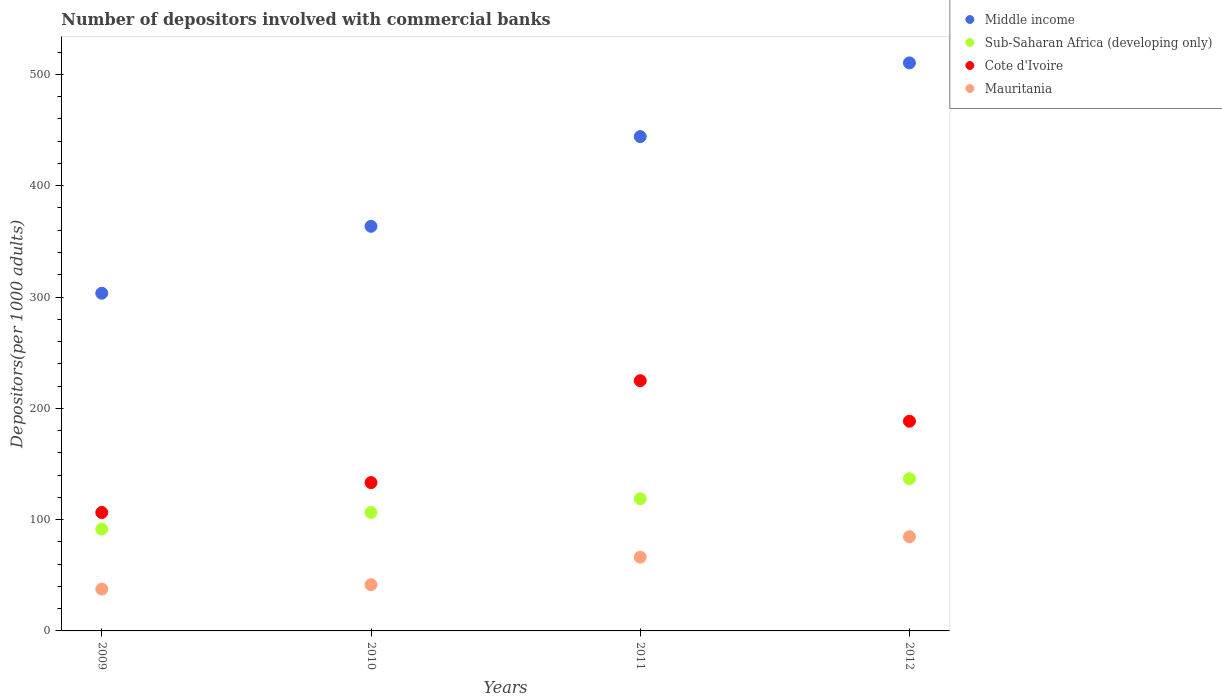What is the number of depositors involved with commercial banks in Middle income in 2012?
Offer a very short reply. 510.34. Across all years, what is the maximum number of depositors involved with commercial banks in Cote d'Ivoire?
Your answer should be compact. 224.81. Across all years, what is the minimum number of depositors involved with commercial banks in Cote d'Ivoire?
Your answer should be very brief. 106.41. What is the total number of depositors involved with commercial banks in Mauritania in the graph?
Your answer should be compact. 229.98. What is the difference between the number of depositors involved with commercial banks in Middle income in 2009 and that in 2011?
Provide a succinct answer. -140.73. What is the difference between the number of depositors involved with commercial banks in Mauritania in 2011 and the number of depositors involved with commercial banks in Middle income in 2012?
Your answer should be very brief. -444.11. What is the average number of depositors involved with commercial banks in Mauritania per year?
Offer a very short reply. 57.5. In the year 2012, what is the difference between the number of depositors involved with commercial banks in Middle income and number of depositors involved with commercial banks in Cote d'Ivoire?
Keep it short and to the point. 321.94. What is the ratio of the number of depositors involved with commercial banks in Sub-Saharan Africa (developing only) in 2009 to that in 2011?
Your answer should be very brief. 0.77. Is the number of depositors involved with commercial banks in Cote d'Ivoire in 2010 less than that in 2011?
Ensure brevity in your answer.  Yes. What is the difference between the highest and the second highest number of depositors involved with commercial banks in Cote d'Ivoire?
Your answer should be very brief. 36.42. What is the difference between the highest and the lowest number of depositors involved with commercial banks in Cote d'Ivoire?
Offer a terse response. 118.41. In how many years, is the number of depositors involved with commercial banks in Sub-Saharan Africa (developing only) greater than the average number of depositors involved with commercial banks in Sub-Saharan Africa (developing only) taken over all years?
Your response must be concise. 2. Is it the case that in every year, the sum of the number of depositors involved with commercial banks in Mauritania and number of depositors involved with commercial banks in Sub-Saharan Africa (developing only)  is greater than the sum of number of depositors involved with commercial banks in Cote d'Ivoire and number of depositors involved with commercial banks in Middle income?
Keep it short and to the point. No. Is it the case that in every year, the sum of the number of depositors involved with commercial banks in Sub-Saharan Africa (developing only) and number of depositors involved with commercial banks in Cote d'Ivoire  is greater than the number of depositors involved with commercial banks in Mauritania?
Give a very brief answer. Yes. Does the number of depositors involved with commercial banks in Sub-Saharan Africa (developing only) monotonically increase over the years?
Your answer should be very brief. Yes. How many dotlines are there?
Give a very brief answer. 4. What is the difference between two consecutive major ticks on the Y-axis?
Provide a succinct answer. 100. Are the values on the major ticks of Y-axis written in scientific E-notation?
Your answer should be compact. No. How are the legend labels stacked?
Provide a short and direct response. Vertical. What is the title of the graph?
Keep it short and to the point. Number of depositors involved with commercial banks. What is the label or title of the X-axis?
Offer a very short reply. Years. What is the label or title of the Y-axis?
Ensure brevity in your answer.  Depositors(per 1000 adults). What is the Depositors(per 1000 adults) in Middle income in 2009?
Give a very brief answer. 303.38. What is the Depositors(per 1000 adults) of Sub-Saharan Africa (developing only) in 2009?
Keep it short and to the point. 91.54. What is the Depositors(per 1000 adults) in Cote d'Ivoire in 2009?
Your answer should be compact. 106.41. What is the Depositors(per 1000 adults) of Mauritania in 2009?
Provide a short and direct response. 37.6. What is the Depositors(per 1000 adults) in Middle income in 2010?
Keep it short and to the point. 363.5. What is the Depositors(per 1000 adults) in Sub-Saharan Africa (developing only) in 2010?
Your response must be concise. 106.49. What is the Depositors(per 1000 adults) in Cote d'Ivoire in 2010?
Offer a very short reply. 133.26. What is the Depositors(per 1000 adults) in Mauritania in 2010?
Offer a very short reply. 41.54. What is the Depositors(per 1000 adults) in Middle income in 2011?
Keep it short and to the point. 444.11. What is the Depositors(per 1000 adults) in Sub-Saharan Africa (developing only) in 2011?
Offer a terse response. 118.8. What is the Depositors(per 1000 adults) of Cote d'Ivoire in 2011?
Give a very brief answer. 224.81. What is the Depositors(per 1000 adults) of Mauritania in 2011?
Provide a succinct answer. 66.23. What is the Depositors(per 1000 adults) of Middle income in 2012?
Provide a succinct answer. 510.34. What is the Depositors(per 1000 adults) in Sub-Saharan Africa (developing only) in 2012?
Ensure brevity in your answer.  136.78. What is the Depositors(per 1000 adults) of Cote d'Ivoire in 2012?
Offer a terse response. 188.4. What is the Depositors(per 1000 adults) of Mauritania in 2012?
Your response must be concise. 84.61. Across all years, what is the maximum Depositors(per 1000 adults) in Middle income?
Your response must be concise. 510.34. Across all years, what is the maximum Depositors(per 1000 adults) of Sub-Saharan Africa (developing only)?
Provide a short and direct response. 136.78. Across all years, what is the maximum Depositors(per 1000 adults) of Cote d'Ivoire?
Keep it short and to the point. 224.81. Across all years, what is the maximum Depositors(per 1000 adults) in Mauritania?
Your answer should be very brief. 84.61. Across all years, what is the minimum Depositors(per 1000 adults) of Middle income?
Offer a terse response. 303.38. Across all years, what is the minimum Depositors(per 1000 adults) of Sub-Saharan Africa (developing only)?
Your answer should be very brief. 91.54. Across all years, what is the minimum Depositors(per 1000 adults) of Cote d'Ivoire?
Keep it short and to the point. 106.41. Across all years, what is the minimum Depositors(per 1000 adults) of Mauritania?
Your answer should be very brief. 37.6. What is the total Depositors(per 1000 adults) of Middle income in the graph?
Your response must be concise. 1621.33. What is the total Depositors(per 1000 adults) of Sub-Saharan Africa (developing only) in the graph?
Offer a terse response. 453.62. What is the total Depositors(per 1000 adults) of Cote d'Ivoire in the graph?
Give a very brief answer. 652.87. What is the total Depositors(per 1000 adults) in Mauritania in the graph?
Your response must be concise. 229.98. What is the difference between the Depositors(per 1000 adults) of Middle income in 2009 and that in 2010?
Your answer should be very brief. -60.11. What is the difference between the Depositors(per 1000 adults) of Sub-Saharan Africa (developing only) in 2009 and that in 2010?
Provide a short and direct response. -14.95. What is the difference between the Depositors(per 1000 adults) of Cote d'Ivoire in 2009 and that in 2010?
Ensure brevity in your answer.  -26.85. What is the difference between the Depositors(per 1000 adults) in Mauritania in 2009 and that in 2010?
Offer a terse response. -3.93. What is the difference between the Depositors(per 1000 adults) of Middle income in 2009 and that in 2011?
Your response must be concise. -140.73. What is the difference between the Depositors(per 1000 adults) of Sub-Saharan Africa (developing only) in 2009 and that in 2011?
Make the answer very short. -27.26. What is the difference between the Depositors(per 1000 adults) in Cote d'Ivoire in 2009 and that in 2011?
Provide a succinct answer. -118.41. What is the difference between the Depositors(per 1000 adults) of Mauritania in 2009 and that in 2011?
Provide a succinct answer. -28.63. What is the difference between the Depositors(per 1000 adults) of Middle income in 2009 and that in 2012?
Keep it short and to the point. -206.95. What is the difference between the Depositors(per 1000 adults) in Sub-Saharan Africa (developing only) in 2009 and that in 2012?
Give a very brief answer. -45.24. What is the difference between the Depositors(per 1000 adults) of Cote d'Ivoire in 2009 and that in 2012?
Ensure brevity in your answer.  -81.99. What is the difference between the Depositors(per 1000 adults) of Mauritania in 2009 and that in 2012?
Keep it short and to the point. -47.01. What is the difference between the Depositors(per 1000 adults) of Middle income in 2010 and that in 2011?
Keep it short and to the point. -80.61. What is the difference between the Depositors(per 1000 adults) of Sub-Saharan Africa (developing only) in 2010 and that in 2011?
Ensure brevity in your answer.  -12.31. What is the difference between the Depositors(per 1000 adults) in Cote d'Ivoire in 2010 and that in 2011?
Keep it short and to the point. -91.56. What is the difference between the Depositors(per 1000 adults) of Mauritania in 2010 and that in 2011?
Ensure brevity in your answer.  -24.69. What is the difference between the Depositors(per 1000 adults) in Middle income in 2010 and that in 2012?
Ensure brevity in your answer.  -146.84. What is the difference between the Depositors(per 1000 adults) in Sub-Saharan Africa (developing only) in 2010 and that in 2012?
Ensure brevity in your answer.  -30.29. What is the difference between the Depositors(per 1000 adults) of Cote d'Ivoire in 2010 and that in 2012?
Provide a succinct answer. -55.14. What is the difference between the Depositors(per 1000 adults) of Mauritania in 2010 and that in 2012?
Keep it short and to the point. -43.07. What is the difference between the Depositors(per 1000 adults) of Middle income in 2011 and that in 2012?
Make the answer very short. -66.23. What is the difference between the Depositors(per 1000 adults) in Sub-Saharan Africa (developing only) in 2011 and that in 2012?
Keep it short and to the point. -17.98. What is the difference between the Depositors(per 1000 adults) in Cote d'Ivoire in 2011 and that in 2012?
Offer a very short reply. 36.42. What is the difference between the Depositors(per 1000 adults) of Mauritania in 2011 and that in 2012?
Make the answer very short. -18.38. What is the difference between the Depositors(per 1000 adults) in Middle income in 2009 and the Depositors(per 1000 adults) in Sub-Saharan Africa (developing only) in 2010?
Ensure brevity in your answer.  196.89. What is the difference between the Depositors(per 1000 adults) in Middle income in 2009 and the Depositors(per 1000 adults) in Cote d'Ivoire in 2010?
Make the answer very short. 170.13. What is the difference between the Depositors(per 1000 adults) in Middle income in 2009 and the Depositors(per 1000 adults) in Mauritania in 2010?
Your answer should be very brief. 261.85. What is the difference between the Depositors(per 1000 adults) of Sub-Saharan Africa (developing only) in 2009 and the Depositors(per 1000 adults) of Cote d'Ivoire in 2010?
Make the answer very short. -41.71. What is the difference between the Depositors(per 1000 adults) in Sub-Saharan Africa (developing only) in 2009 and the Depositors(per 1000 adults) in Mauritania in 2010?
Ensure brevity in your answer.  50.01. What is the difference between the Depositors(per 1000 adults) in Cote d'Ivoire in 2009 and the Depositors(per 1000 adults) in Mauritania in 2010?
Offer a terse response. 64.87. What is the difference between the Depositors(per 1000 adults) of Middle income in 2009 and the Depositors(per 1000 adults) of Sub-Saharan Africa (developing only) in 2011?
Your response must be concise. 184.58. What is the difference between the Depositors(per 1000 adults) of Middle income in 2009 and the Depositors(per 1000 adults) of Cote d'Ivoire in 2011?
Ensure brevity in your answer.  78.57. What is the difference between the Depositors(per 1000 adults) of Middle income in 2009 and the Depositors(per 1000 adults) of Mauritania in 2011?
Your answer should be compact. 237.15. What is the difference between the Depositors(per 1000 adults) in Sub-Saharan Africa (developing only) in 2009 and the Depositors(per 1000 adults) in Cote d'Ivoire in 2011?
Offer a very short reply. -133.27. What is the difference between the Depositors(per 1000 adults) in Sub-Saharan Africa (developing only) in 2009 and the Depositors(per 1000 adults) in Mauritania in 2011?
Your response must be concise. 25.31. What is the difference between the Depositors(per 1000 adults) of Cote d'Ivoire in 2009 and the Depositors(per 1000 adults) of Mauritania in 2011?
Your response must be concise. 40.18. What is the difference between the Depositors(per 1000 adults) in Middle income in 2009 and the Depositors(per 1000 adults) in Sub-Saharan Africa (developing only) in 2012?
Provide a short and direct response. 166.6. What is the difference between the Depositors(per 1000 adults) in Middle income in 2009 and the Depositors(per 1000 adults) in Cote d'Ivoire in 2012?
Ensure brevity in your answer.  114.99. What is the difference between the Depositors(per 1000 adults) of Middle income in 2009 and the Depositors(per 1000 adults) of Mauritania in 2012?
Give a very brief answer. 218.77. What is the difference between the Depositors(per 1000 adults) of Sub-Saharan Africa (developing only) in 2009 and the Depositors(per 1000 adults) of Cote d'Ivoire in 2012?
Your answer should be compact. -96.86. What is the difference between the Depositors(per 1000 adults) in Sub-Saharan Africa (developing only) in 2009 and the Depositors(per 1000 adults) in Mauritania in 2012?
Your answer should be very brief. 6.93. What is the difference between the Depositors(per 1000 adults) in Cote d'Ivoire in 2009 and the Depositors(per 1000 adults) in Mauritania in 2012?
Your answer should be compact. 21.79. What is the difference between the Depositors(per 1000 adults) of Middle income in 2010 and the Depositors(per 1000 adults) of Sub-Saharan Africa (developing only) in 2011?
Give a very brief answer. 244.69. What is the difference between the Depositors(per 1000 adults) in Middle income in 2010 and the Depositors(per 1000 adults) in Cote d'Ivoire in 2011?
Provide a succinct answer. 138.68. What is the difference between the Depositors(per 1000 adults) in Middle income in 2010 and the Depositors(per 1000 adults) in Mauritania in 2011?
Give a very brief answer. 297.27. What is the difference between the Depositors(per 1000 adults) of Sub-Saharan Africa (developing only) in 2010 and the Depositors(per 1000 adults) of Cote d'Ivoire in 2011?
Offer a terse response. -118.32. What is the difference between the Depositors(per 1000 adults) in Sub-Saharan Africa (developing only) in 2010 and the Depositors(per 1000 adults) in Mauritania in 2011?
Your answer should be very brief. 40.26. What is the difference between the Depositors(per 1000 adults) in Cote d'Ivoire in 2010 and the Depositors(per 1000 adults) in Mauritania in 2011?
Provide a short and direct response. 67.02. What is the difference between the Depositors(per 1000 adults) of Middle income in 2010 and the Depositors(per 1000 adults) of Sub-Saharan Africa (developing only) in 2012?
Your answer should be compact. 226.71. What is the difference between the Depositors(per 1000 adults) in Middle income in 2010 and the Depositors(per 1000 adults) in Cote d'Ivoire in 2012?
Provide a short and direct response. 175.1. What is the difference between the Depositors(per 1000 adults) of Middle income in 2010 and the Depositors(per 1000 adults) of Mauritania in 2012?
Ensure brevity in your answer.  278.88. What is the difference between the Depositors(per 1000 adults) of Sub-Saharan Africa (developing only) in 2010 and the Depositors(per 1000 adults) of Cote d'Ivoire in 2012?
Give a very brief answer. -81.91. What is the difference between the Depositors(per 1000 adults) of Sub-Saharan Africa (developing only) in 2010 and the Depositors(per 1000 adults) of Mauritania in 2012?
Offer a terse response. 21.88. What is the difference between the Depositors(per 1000 adults) of Cote d'Ivoire in 2010 and the Depositors(per 1000 adults) of Mauritania in 2012?
Your answer should be very brief. 48.64. What is the difference between the Depositors(per 1000 adults) of Middle income in 2011 and the Depositors(per 1000 adults) of Sub-Saharan Africa (developing only) in 2012?
Offer a very short reply. 307.33. What is the difference between the Depositors(per 1000 adults) of Middle income in 2011 and the Depositors(per 1000 adults) of Cote d'Ivoire in 2012?
Your answer should be very brief. 255.71. What is the difference between the Depositors(per 1000 adults) of Middle income in 2011 and the Depositors(per 1000 adults) of Mauritania in 2012?
Keep it short and to the point. 359.5. What is the difference between the Depositors(per 1000 adults) of Sub-Saharan Africa (developing only) in 2011 and the Depositors(per 1000 adults) of Cote d'Ivoire in 2012?
Your response must be concise. -69.59. What is the difference between the Depositors(per 1000 adults) of Sub-Saharan Africa (developing only) in 2011 and the Depositors(per 1000 adults) of Mauritania in 2012?
Make the answer very short. 34.19. What is the difference between the Depositors(per 1000 adults) of Cote d'Ivoire in 2011 and the Depositors(per 1000 adults) of Mauritania in 2012?
Make the answer very short. 140.2. What is the average Depositors(per 1000 adults) of Middle income per year?
Provide a succinct answer. 405.33. What is the average Depositors(per 1000 adults) in Sub-Saharan Africa (developing only) per year?
Give a very brief answer. 113.41. What is the average Depositors(per 1000 adults) of Cote d'Ivoire per year?
Keep it short and to the point. 163.22. What is the average Depositors(per 1000 adults) in Mauritania per year?
Offer a terse response. 57.5. In the year 2009, what is the difference between the Depositors(per 1000 adults) of Middle income and Depositors(per 1000 adults) of Sub-Saharan Africa (developing only)?
Keep it short and to the point. 211.84. In the year 2009, what is the difference between the Depositors(per 1000 adults) in Middle income and Depositors(per 1000 adults) in Cote d'Ivoire?
Make the answer very short. 196.98. In the year 2009, what is the difference between the Depositors(per 1000 adults) in Middle income and Depositors(per 1000 adults) in Mauritania?
Ensure brevity in your answer.  265.78. In the year 2009, what is the difference between the Depositors(per 1000 adults) of Sub-Saharan Africa (developing only) and Depositors(per 1000 adults) of Cote d'Ivoire?
Your answer should be very brief. -14.86. In the year 2009, what is the difference between the Depositors(per 1000 adults) of Sub-Saharan Africa (developing only) and Depositors(per 1000 adults) of Mauritania?
Make the answer very short. 53.94. In the year 2009, what is the difference between the Depositors(per 1000 adults) in Cote d'Ivoire and Depositors(per 1000 adults) in Mauritania?
Offer a terse response. 68.8. In the year 2010, what is the difference between the Depositors(per 1000 adults) of Middle income and Depositors(per 1000 adults) of Sub-Saharan Africa (developing only)?
Keep it short and to the point. 257.01. In the year 2010, what is the difference between the Depositors(per 1000 adults) in Middle income and Depositors(per 1000 adults) in Cote d'Ivoire?
Your answer should be compact. 230.24. In the year 2010, what is the difference between the Depositors(per 1000 adults) in Middle income and Depositors(per 1000 adults) in Mauritania?
Keep it short and to the point. 321.96. In the year 2010, what is the difference between the Depositors(per 1000 adults) in Sub-Saharan Africa (developing only) and Depositors(per 1000 adults) in Cote d'Ivoire?
Provide a succinct answer. -26.77. In the year 2010, what is the difference between the Depositors(per 1000 adults) of Sub-Saharan Africa (developing only) and Depositors(per 1000 adults) of Mauritania?
Keep it short and to the point. 64.95. In the year 2010, what is the difference between the Depositors(per 1000 adults) in Cote d'Ivoire and Depositors(per 1000 adults) in Mauritania?
Your answer should be compact. 91.72. In the year 2011, what is the difference between the Depositors(per 1000 adults) in Middle income and Depositors(per 1000 adults) in Sub-Saharan Africa (developing only)?
Provide a short and direct response. 325.31. In the year 2011, what is the difference between the Depositors(per 1000 adults) of Middle income and Depositors(per 1000 adults) of Cote d'Ivoire?
Ensure brevity in your answer.  219.3. In the year 2011, what is the difference between the Depositors(per 1000 adults) of Middle income and Depositors(per 1000 adults) of Mauritania?
Your answer should be compact. 377.88. In the year 2011, what is the difference between the Depositors(per 1000 adults) of Sub-Saharan Africa (developing only) and Depositors(per 1000 adults) of Cote d'Ivoire?
Provide a succinct answer. -106.01. In the year 2011, what is the difference between the Depositors(per 1000 adults) of Sub-Saharan Africa (developing only) and Depositors(per 1000 adults) of Mauritania?
Make the answer very short. 52.57. In the year 2011, what is the difference between the Depositors(per 1000 adults) in Cote d'Ivoire and Depositors(per 1000 adults) in Mauritania?
Give a very brief answer. 158.58. In the year 2012, what is the difference between the Depositors(per 1000 adults) in Middle income and Depositors(per 1000 adults) in Sub-Saharan Africa (developing only)?
Your answer should be compact. 373.55. In the year 2012, what is the difference between the Depositors(per 1000 adults) in Middle income and Depositors(per 1000 adults) in Cote d'Ivoire?
Your answer should be very brief. 321.94. In the year 2012, what is the difference between the Depositors(per 1000 adults) in Middle income and Depositors(per 1000 adults) in Mauritania?
Keep it short and to the point. 425.72. In the year 2012, what is the difference between the Depositors(per 1000 adults) of Sub-Saharan Africa (developing only) and Depositors(per 1000 adults) of Cote d'Ivoire?
Keep it short and to the point. -51.61. In the year 2012, what is the difference between the Depositors(per 1000 adults) of Sub-Saharan Africa (developing only) and Depositors(per 1000 adults) of Mauritania?
Make the answer very short. 52.17. In the year 2012, what is the difference between the Depositors(per 1000 adults) of Cote d'Ivoire and Depositors(per 1000 adults) of Mauritania?
Offer a terse response. 103.79. What is the ratio of the Depositors(per 1000 adults) of Middle income in 2009 to that in 2010?
Your answer should be very brief. 0.83. What is the ratio of the Depositors(per 1000 adults) in Sub-Saharan Africa (developing only) in 2009 to that in 2010?
Keep it short and to the point. 0.86. What is the ratio of the Depositors(per 1000 adults) of Cote d'Ivoire in 2009 to that in 2010?
Give a very brief answer. 0.8. What is the ratio of the Depositors(per 1000 adults) of Mauritania in 2009 to that in 2010?
Give a very brief answer. 0.91. What is the ratio of the Depositors(per 1000 adults) in Middle income in 2009 to that in 2011?
Your response must be concise. 0.68. What is the ratio of the Depositors(per 1000 adults) of Sub-Saharan Africa (developing only) in 2009 to that in 2011?
Provide a succinct answer. 0.77. What is the ratio of the Depositors(per 1000 adults) in Cote d'Ivoire in 2009 to that in 2011?
Provide a succinct answer. 0.47. What is the ratio of the Depositors(per 1000 adults) of Mauritania in 2009 to that in 2011?
Your answer should be compact. 0.57. What is the ratio of the Depositors(per 1000 adults) of Middle income in 2009 to that in 2012?
Provide a short and direct response. 0.59. What is the ratio of the Depositors(per 1000 adults) in Sub-Saharan Africa (developing only) in 2009 to that in 2012?
Make the answer very short. 0.67. What is the ratio of the Depositors(per 1000 adults) of Cote d'Ivoire in 2009 to that in 2012?
Make the answer very short. 0.56. What is the ratio of the Depositors(per 1000 adults) in Mauritania in 2009 to that in 2012?
Provide a succinct answer. 0.44. What is the ratio of the Depositors(per 1000 adults) of Middle income in 2010 to that in 2011?
Provide a short and direct response. 0.82. What is the ratio of the Depositors(per 1000 adults) in Sub-Saharan Africa (developing only) in 2010 to that in 2011?
Offer a very short reply. 0.9. What is the ratio of the Depositors(per 1000 adults) of Cote d'Ivoire in 2010 to that in 2011?
Provide a succinct answer. 0.59. What is the ratio of the Depositors(per 1000 adults) of Mauritania in 2010 to that in 2011?
Your answer should be very brief. 0.63. What is the ratio of the Depositors(per 1000 adults) of Middle income in 2010 to that in 2012?
Offer a very short reply. 0.71. What is the ratio of the Depositors(per 1000 adults) in Sub-Saharan Africa (developing only) in 2010 to that in 2012?
Your answer should be very brief. 0.78. What is the ratio of the Depositors(per 1000 adults) of Cote d'Ivoire in 2010 to that in 2012?
Your answer should be compact. 0.71. What is the ratio of the Depositors(per 1000 adults) of Mauritania in 2010 to that in 2012?
Provide a succinct answer. 0.49. What is the ratio of the Depositors(per 1000 adults) in Middle income in 2011 to that in 2012?
Make the answer very short. 0.87. What is the ratio of the Depositors(per 1000 adults) of Sub-Saharan Africa (developing only) in 2011 to that in 2012?
Provide a short and direct response. 0.87. What is the ratio of the Depositors(per 1000 adults) of Cote d'Ivoire in 2011 to that in 2012?
Your response must be concise. 1.19. What is the ratio of the Depositors(per 1000 adults) in Mauritania in 2011 to that in 2012?
Your answer should be compact. 0.78. What is the difference between the highest and the second highest Depositors(per 1000 adults) in Middle income?
Provide a succinct answer. 66.23. What is the difference between the highest and the second highest Depositors(per 1000 adults) in Sub-Saharan Africa (developing only)?
Provide a short and direct response. 17.98. What is the difference between the highest and the second highest Depositors(per 1000 adults) of Cote d'Ivoire?
Ensure brevity in your answer.  36.42. What is the difference between the highest and the second highest Depositors(per 1000 adults) of Mauritania?
Give a very brief answer. 18.38. What is the difference between the highest and the lowest Depositors(per 1000 adults) of Middle income?
Your answer should be compact. 206.95. What is the difference between the highest and the lowest Depositors(per 1000 adults) of Sub-Saharan Africa (developing only)?
Offer a very short reply. 45.24. What is the difference between the highest and the lowest Depositors(per 1000 adults) in Cote d'Ivoire?
Your response must be concise. 118.41. What is the difference between the highest and the lowest Depositors(per 1000 adults) in Mauritania?
Offer a terse response. 47.01. 